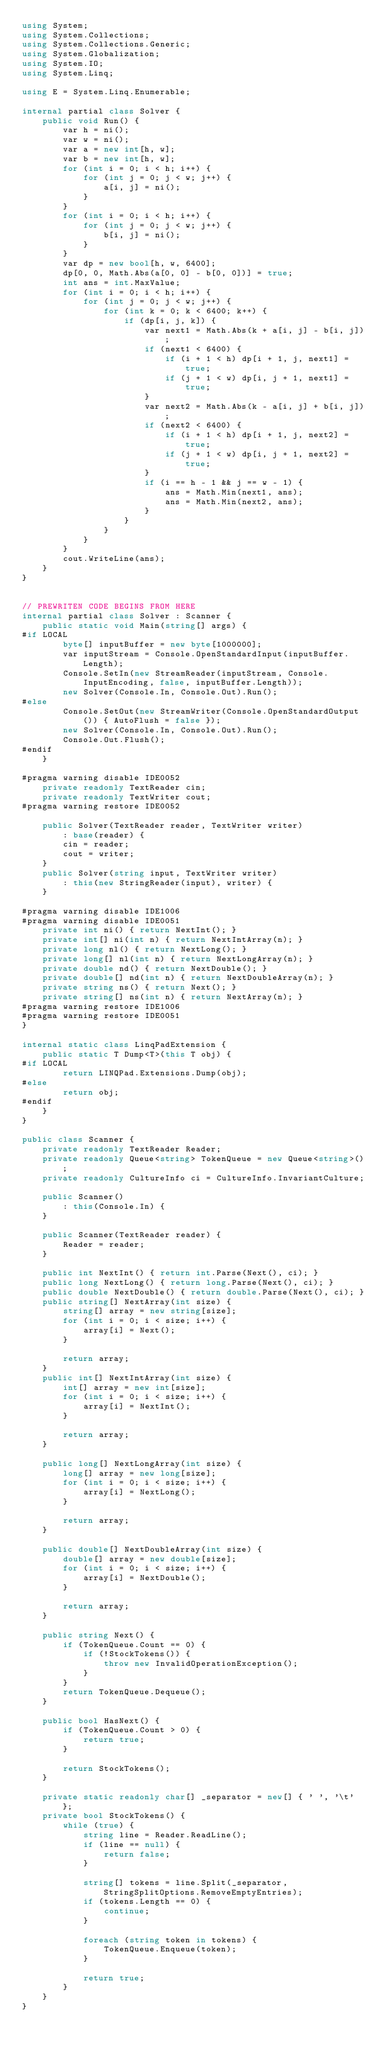<code> <loc_0><loc_0><loc_500><loc_500><_C#_>using System;
using System.Collections;
using System.Collections.Generic;
using System.Globalization;
using System.IO;
using System.Linq;

using E = System.Linq.Enumerable;

internal partial class Solver {
    public void Run() {
        var h = ni();
        var w = ni();
        var a = new int[h, w];
        var b = new int[h, w];
        for (int i = 0; i < h; i++) {
            for (int j = 0; j < w; j++) {
                a[i, j] = ni();
            }
        }
        for (int i = 0; i < h; i++) {
            for (int j = 0; j < w; j++) {
                b[i, j] = ni();
            }
        }
        var dp = new bool[h, w, 6400];
        dp[0, 0, Math.Abs(a[0, 0] - b[0, 0])] = true;
        int ans = int.MaxValue;
        for (int i = 0; i < h; i++) {
            for (int j = 0; j < w; j++) {
                for (int k = 0; k < 6400; k++) {
                    if (dp[i, j, k]) {
                        var next1 = Math.Abs(k + a[i, j] - b[i, j]);
                        if (next1 < 6400) {
                            if (i + 1 < h) dp[i + 1, j, next1] = true;
                            if (j + 1 < w) dp[i, j + 1, next1] = true;
                        }
                        var next2 = Math.Abs(k - a[i, j] + b[i, j]);
                        if (next2 < 6400) {
                            if (i + 1 < h) dp[i + 1, j, next2] = true;
                            if (j + 1 < w) dp[i, j + 1, next2] = true;
                        }
                        if (i == h - 1 && j == w - 1) {
                            ans = Math.Min(next1, ans);
                            ans = Math.Min(next2, ans);
                        }
                    }
                }
            }
        }
        cout.WriteLine(ans);
    }
}


// PREWRITEN CODE BEGINS FROM HERE
internal partial class Solver : Scanner {
    public static void Main(string[] args) {
#if LOCAL
        byte[] inputBuffer = new byte[1000000];
        var inputStream = Console.OpenStandardInput(inputBuffer.Length);
        Console.SetIn(new StreamReader(inputStream, Console.InputEncoding, false, inputBuffer.Length));
        new Solver(Console.In, Console.Out).Run();
#else
        Console.SetOut(new StreamWriter(Console.OpenStandardOutput()) { AutoFlush = false });
        new Solver(Console.In, Console.Out).Run();
        Console.Out.Flush();
#endif
    }

#pragma warning disable IDE0052
    private readonly TextReader cin;
    private readonly TextWriter cout;
#pragma warning restore IDE0052

    public Solver(TextReader reader, TextWriter writer)
        : base(reader) {
        cin = reader;
        cout = writer;
    }
    public Solver(string input, TextWriter writer)
        : this(new StringReader(input), writer) {
    }

#pragma warning disable IDE1006
#pragma warning disable IDE0051
    private int ni() { return NextInt(); }
    private int[] ni(int n) { return NextIntArray(n); }
    private long nl() { return NextLong(); }
    private long[] nl(int n) { return NextLongArray(n); }
    private double nd() { return NextDouble(); }
    private double[] nd(int n) { return NextDoubleArray(n); }
    private string ns() { return Next(); }
    private string[] ns(int n) { return NextArray(n); }
#pragma warning restore IDE1006
#pragma warning restore IDE0051
}

internal static class LinqPadExtension {
    public static T Dump<T>(this T obj) {
#if LOCAL
        return LINQPad.Extensions.Dump(obj);
#else
        return obj;
#endif
    }
}

public class Scanner {
    private readonly TextReader Reader;
    private readonly Queue<string> TokenQueue = new Queue<string>();
    private readonly CultureInfo ci = CultureInfo.InvariantCulture;

    public Scanner()
        : this(Console.In) {
    }

    public Scanner(TextReader reader) {
        Reader = reader;
    }

    public int NextInt() { return int.Parse(Next(), ci); }
    public long NextLong() { return long.Parse(Next(), ci); }
    public double NextDouble() { return double.Parse(Next(), ci); }
    public string[] NextArray(int size) {
        string[] array = new string[size];
        for (int i = 0; i < size; i++) {
            array[i] = Next();
        }

        return array;
    }
    public int[] NextIntArray(int size) {
        int[] array = new int[size];
        for (int i = 0; i < size; i++) {
            array[i] = NextInt();
        }

        return array;
    }

    public long[] NextLongArray(int size) {
        long[] array = new long[size];
        for (int i = 0; i < size; i++) {
            array[i] = NextLong();
        }

        return array;
    }

    public double[] NextDoubleArray(int size) {
        double[] array = new double[size];
        for (int i = 0; i < size; i++) {
            array[i] = NextDouble();
        }

        return array;
    }

    public string Next() {
        if (TokenQueue.Count == 0) {
            if (!StockTokens()) {
                throw new InvalidOperationException();
            }
        }
        return TokenQueue.Dequeue();
    }

    public bool HasNext() {
        if (TokenQueue.Count > 0) {
            return true;
        }

        return StockTokens();
    }

    private static readonly char[] _separator = new[] { ' ', '\t' };
    private bool StockTokens() {
        while (true) {
            string line = Reader.ReadLine();
            if (line == null) {
                return false;
            }

            string[] tokens = line.Split(_separator, StringSplitOptions.RemoveEmptyEntries);
            if (tokens.Length == 0) {
                continue;
            }

            foreach (string token in tokens) {
                TokenQueue.Enqueue(token);
            }

            return true;
        }
    }
}
</code> 